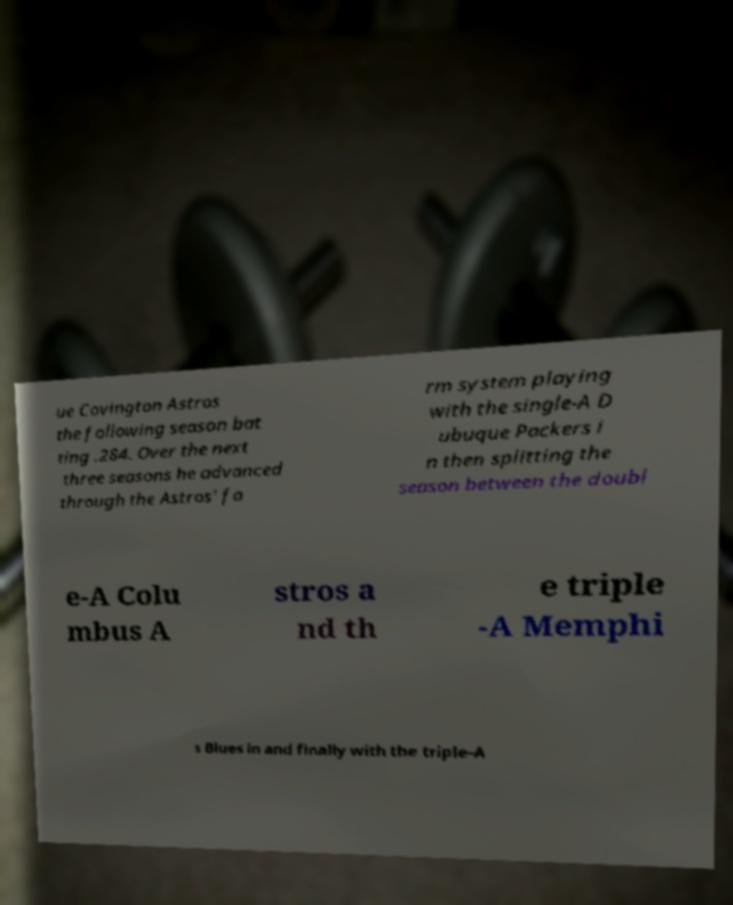Can you accurately transcribe the text from the provided image for me? ue Covington Astros the following season bat ting .284. Over the next three seasons he advanced through the Astros' fa rm system playing with the single-A D ubuque Packers i n then splitting the season between the doubl e-A Colu mbus A stros a nd th e triple -A Memphi s Blues in and finally with the triple-A 